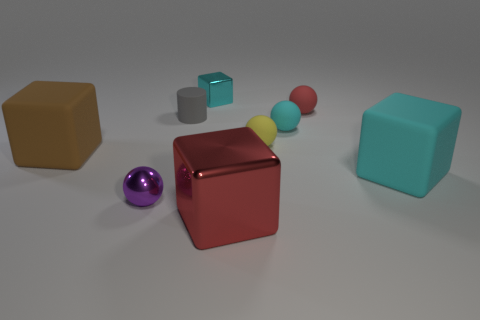Subtract all matte balls. How many balls are left? 1 Add 1 big rubber cylinders. How many objects exist? 10 Subtract all red spheres. How many spheres are left? 3 Subtract all cylinders. How many objects are left? 8 Subtract 0 cyan cylinders. How many objects are left? 9 Subtract 2 cubes. How many cubes are left? 2 Subtract all gray balls. Subtract all red cubes. How many balls are left? 4 Subtract all blue cubes. How many green spheres are left? 0 Subtract all large metallic objects. Subtract all large brown cubes. How many objects are left? 7 Add 5 small purple metallic things. How many small purple metallic things are left? 6 